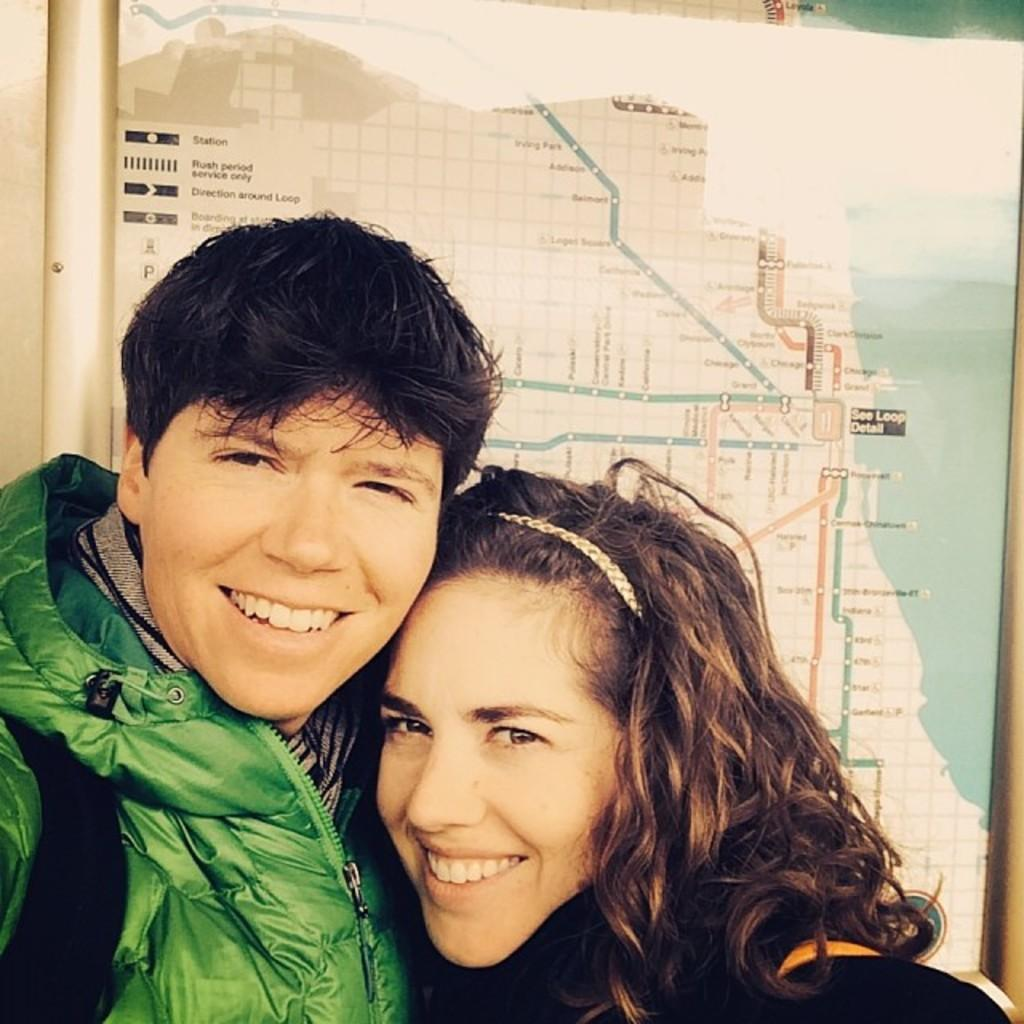How many people are in the image? There are two persons in the image. What are the persons doing in the image? The persons are smiling. What can be seen in the background of the image? There is a board with a route map in the background of the image. What type of corn can be seen growing in the image? There is no corn present in the image. What is the color of the tongue of the person on the left in the image? There is no information about the color of anyone's tongue in the image. 